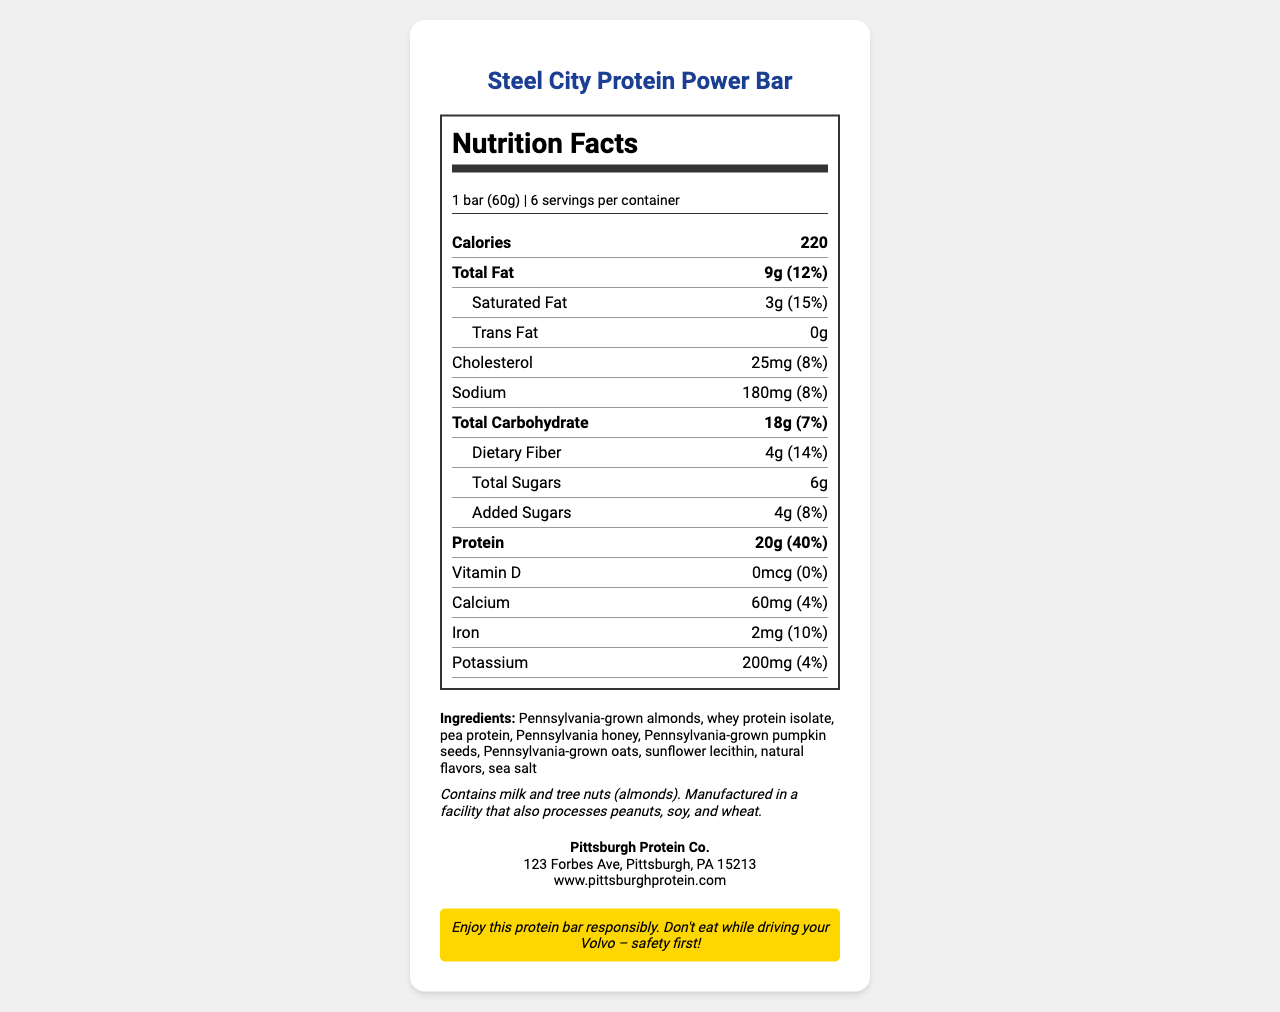what is the serving size for the Steel City Protein Power Bar? The serving size is clearly listed as "1 bar (60g)."
Answer: 1 bar (60g) how many calories are there per serving? The label states that each serving contains 220 calories.
Answer: 220 what percentage of the daily value for protein does one serving provide? The label shows that one serving provides 40% of the daily value for protein.
Answer: 40% what is the total amount of carbohydrates in one bar? The total carbohydrate content per bar is listed as 18g.
Answer: 18g what is the percentage of daily value for saturated fat per serving? The document indicates that the daily value for saturated fat in one serving is 15%.
Answer: 15% how many servings are there in a container? The label mentions that there are 6 servings per container.
Answer: 6 how much dietary fiber does one bar contain? The dietary fiber content is listed as 4g per bar.
Answer: 4g what is the amount of added sugars in one serving? The label states that there are 4g of added sugars per serving.
Answer: 4g which allergen warnings are listed on the label? The label clearly mentions the allergen information under allergen_info.
Answer: Contains milk and tree nuts (almonds). Manufactured in a facility that also processes peanuts, soy, and wheat. who is the manufacturer of this product? The manufacturer is stated as Pittsburgh Protein Co.
Answer: Pittsburgh Protein Co. what is the sodium content in one bar? The sodium content per bar is listed as 180mg.
Answer: 180mg select the ingredients that are Pennsylvania-grown: A. Almonds B. Pumpkin seeds C. Honey D. Whey protein isolate Almonds, pumpkin seeds, and honey are specifically noted as Pennsylvania-grown in the ingredient list.
Answer: A, B, C how much calcium does a serving of this product contain? A. 0% B. 4% C. 10% D. 15% The label indicates that the calcium content is 60mg, which is 4% of the daily value.
Answer: B does this product contain any trans fat? The label clearly states that the product contains 0g of trans fat.
Answer: No summarize the main idea of the document. The document provides comprehensive nutritional and product information for the Steel City Protein Power Bar, highlighting its high protein content and use of local ingredients, along with necessary warnings and manufacturer details.
Answer: The document is a detailed Nutrition Facts label for the Steel City Protein Power Bar, a high-protein, low-carb snack featuring Pennsylvania-grown ingredients. It includes nutritional information, ingredient list, allergen warnings, manufacturer details, and a safety tip for Volvo owners. what color is the background of the document? The document does not provide any visual details regarding its background color.
Answer: Not enough information 